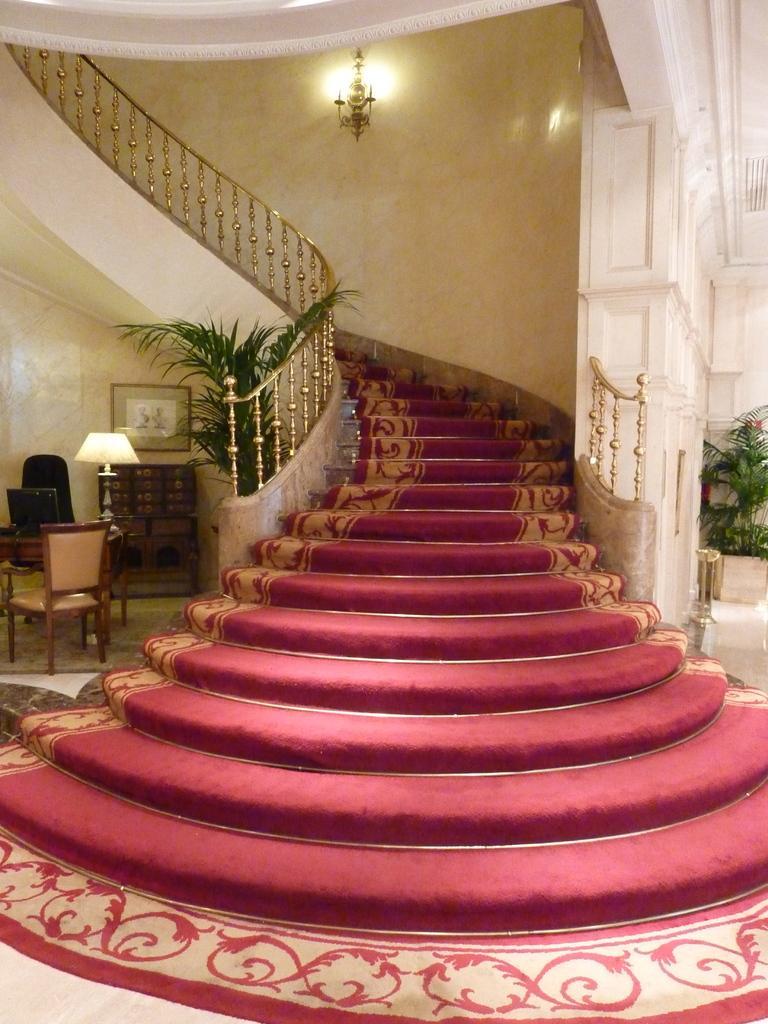Describe this image in one or two sentences. In this image there is a staircase with carpet strips, and there are plants, chair, monitor on the table, lamp, frame and light attached to the wall. 